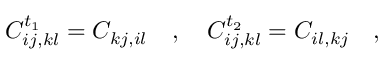<formula> <loc_0><loc_0><loc_500><loc_500>C _ { i j , k l } ^ { t _ { 1 } } = C _ { k j , i l } \quad , \quad C _ { i j , k l } ^ { t _ { 2 } } = C _ { i l , k j } \quad ,</formula> 